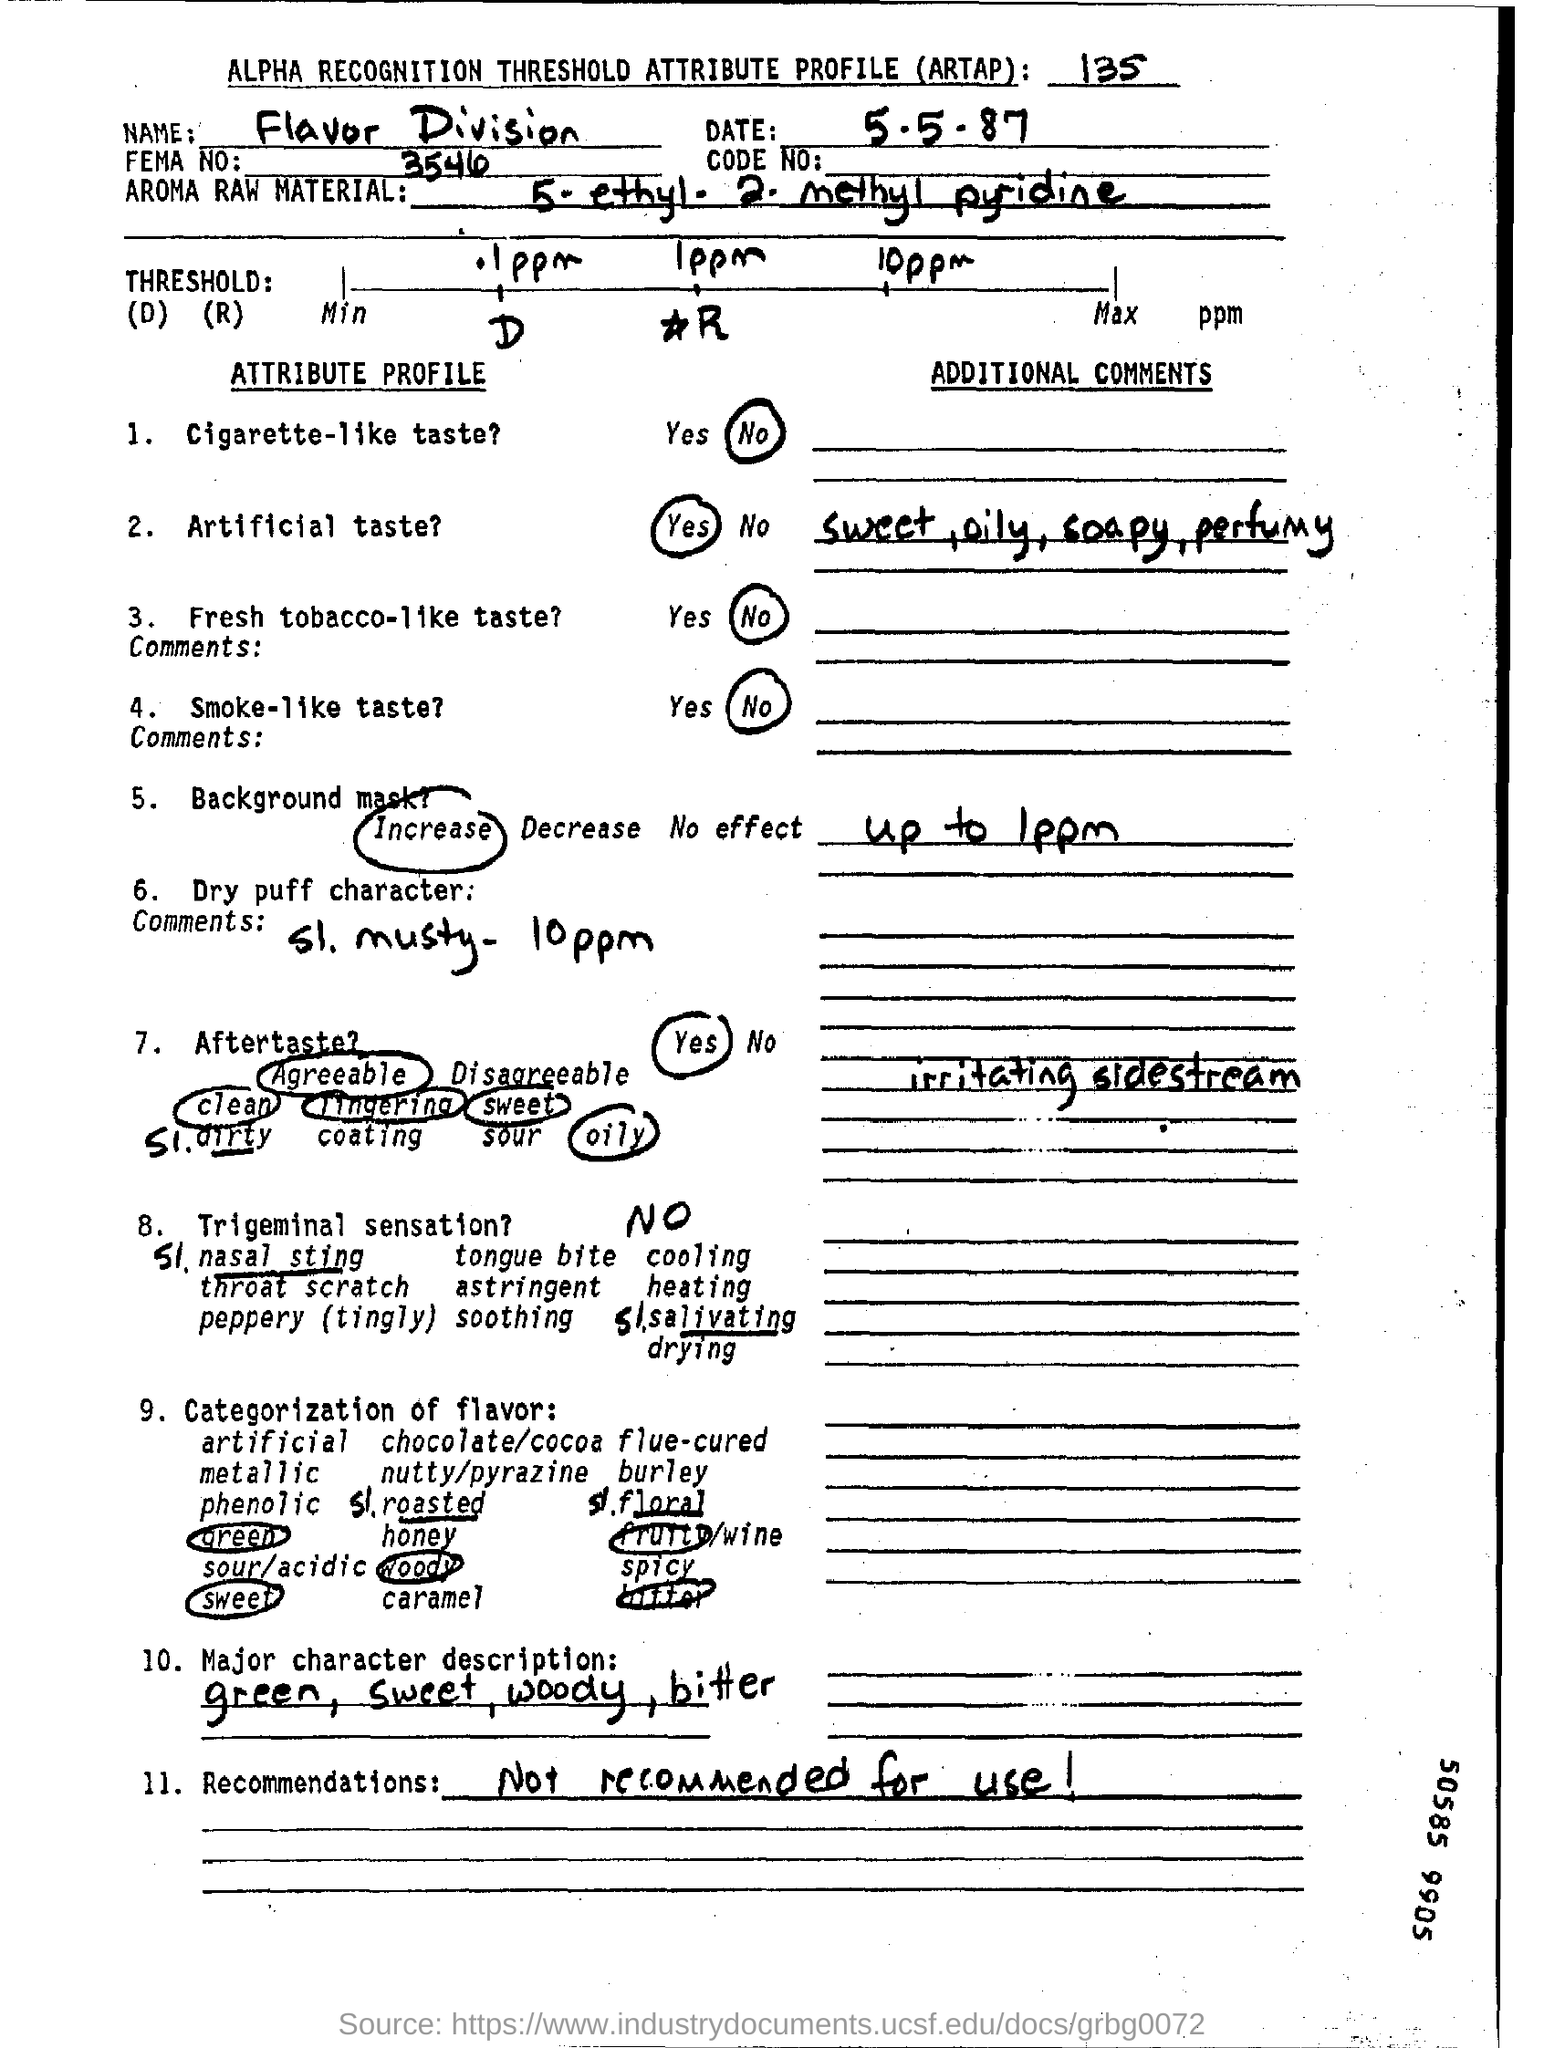Mention a couple of crucial points in this snapshot. It is written in the recommendations field that the item is not recommended for use. The text "Which Name written in the Name field ? flavor division.." appears to be a request for information or a question. Specifically, it seems to be asking about a Name that is written in a certain field (the "Name field") and is related to a flavor division. However, without more context or specific details, it is difficult to determine the exact meaning or purpose of this text. The date mentioned at the top of the document is 5-5-87. 